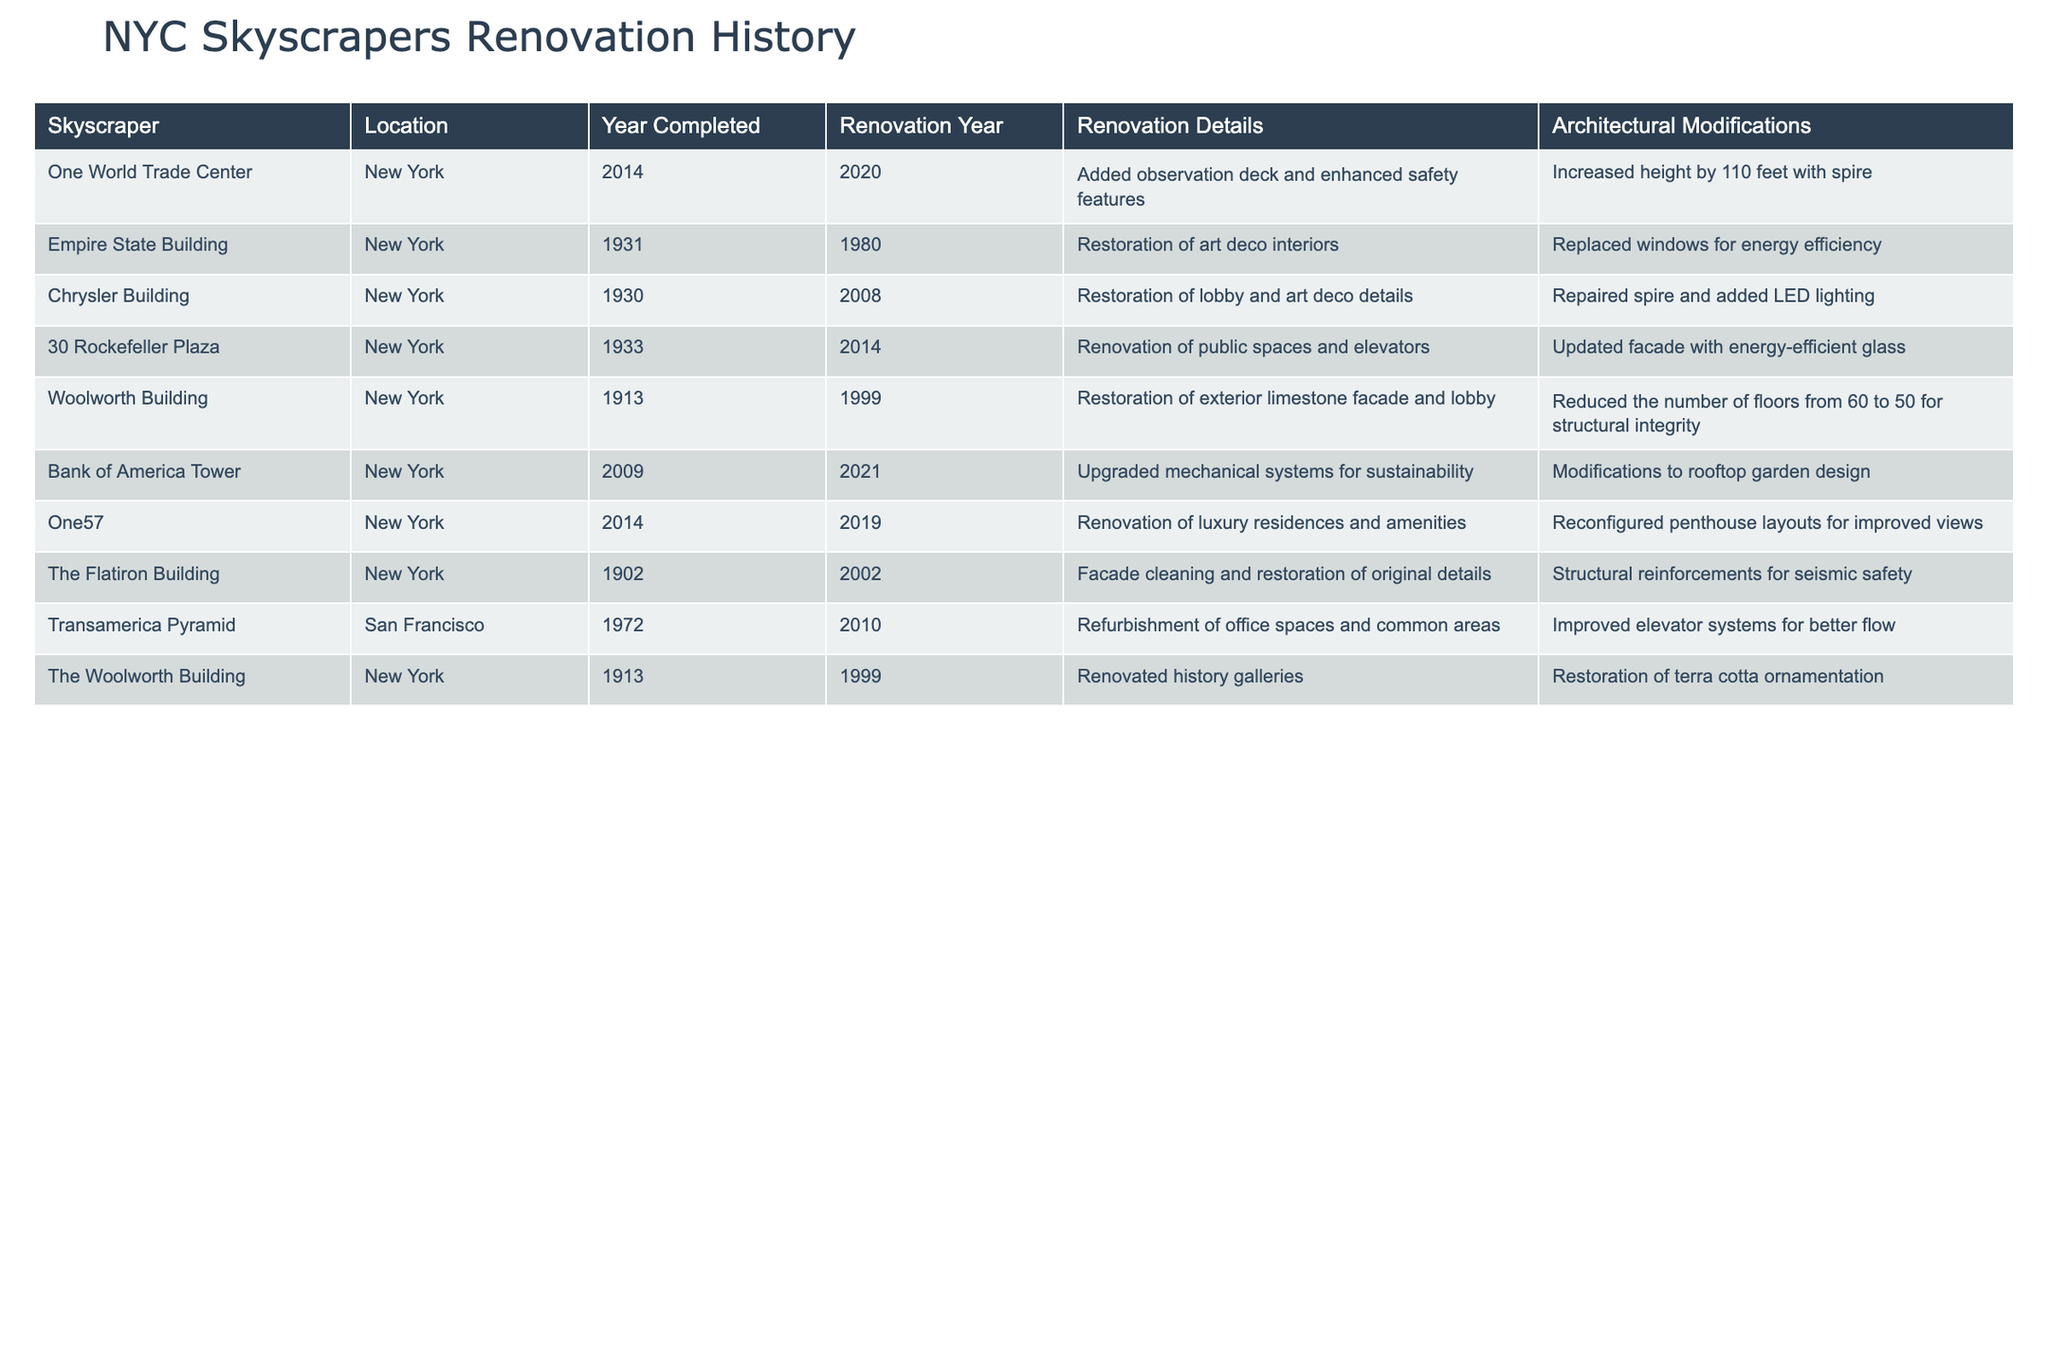What year was the Empire State Building renovated? The table lists the renovation year for the Empire State Building as 1980.
Answer: 1980 What is the total number of floors reduced in the Woolworth Building renovation? The Woolworth Building reduced the number of floors from 60 to 50, which is a decrease of 10 floors.
Answer: 10 Did One57 undergo renovation before 2020? The table indicates that One57 was completed in 2014 and renovated in 2019, confirming it was renovated before 2020.
Answer: Yes Which building's architectural modifications included an increase in height? One World Trade Center's architectural modifications included an increase in height by 110 feet with a spire.
Answer: One World Trade Center How many skyscrapers were completed in the 20th century before 1950 and had renovations? The Empire State Building (1931), Chrysler Building (1930), Woolworth Building (1913), and Flatiron Building (1902) fit this criteria. Therefore, there are four skyscrapers that match.
Answer: 4 What common element is shared between the renovations of the Chrysler Building and the Empire State Building? Both buildings underwent restorations focused on interior details, as indicated by the restoration of art deco interiors for the Empire State Building and the restoration of lobby and art deco details for the Chrysler Building.
Answer: Restoration of interior details Which skyscraper had renovations specifically aimed at enhancing sustainability? The Bank of America Tower's renovation was aimed at upgrading mechanical systems for sustainability.
Answer: Bank of America Tower Identify the skyscraper that had its spire repaired and LED lighting added during renovations. The renovation of the Chrysler Building included the repair of the spire and the addition of LED lighting.
Answer: Chrysler Building How many of the selected skyscrapers have undergone renovations since 2000? The Empire State Building (1980), One World Trade Center (2020), and the Chrysler Building (2008) have all had renovations since 2000. There are six buildings listed that meet this criterion, as the last five skyscrapers listed have renovations from 2002 onwards.
Answer: 6 What unique renovation did One World Trade Center complete? One World Trade Center added an observation deck and enhanced safety features during its renovation in 2020.
Answer: Added an observation deck and enhanced safety features 